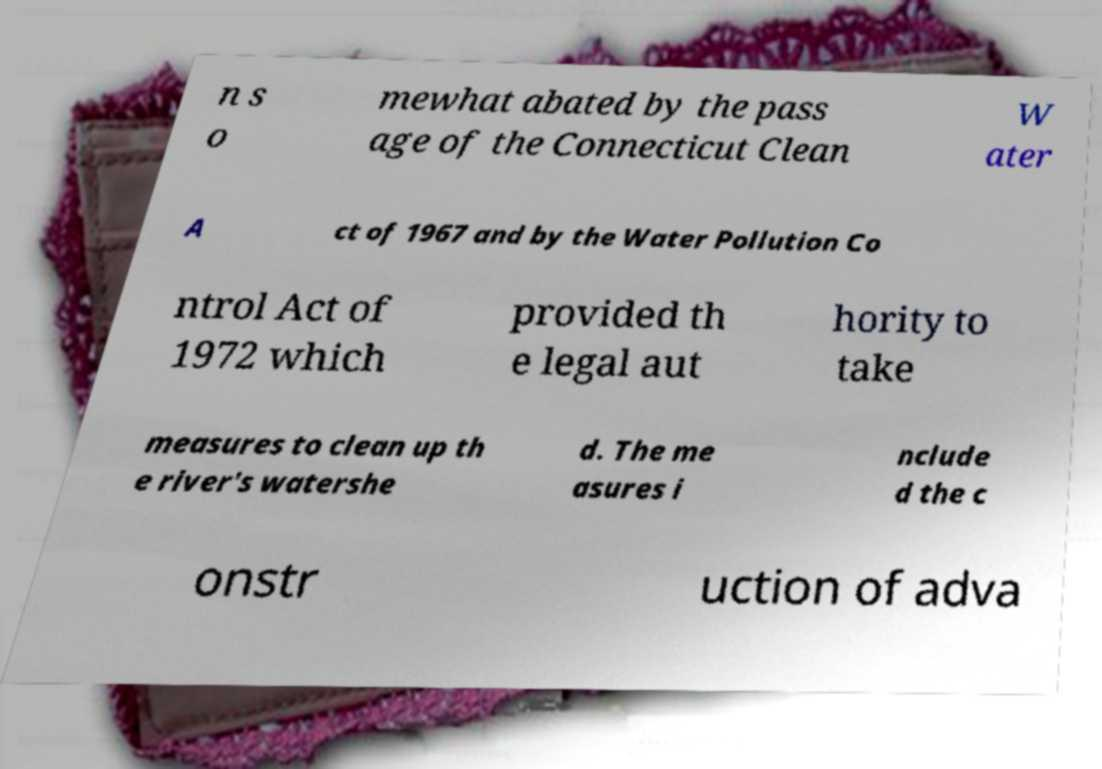What messages or text are displayed in this image? I need them in a readable, typed format. n s o mewhat abated by the pass age of the Connecticut Clean W ater A ct of 1967 and by the Water Pollution Co ntrol Act of 1972 which provided th e legal aut hority to take measures to clean up th e river's watershe d. The me asures i nclude d the c onstr uction of adva 